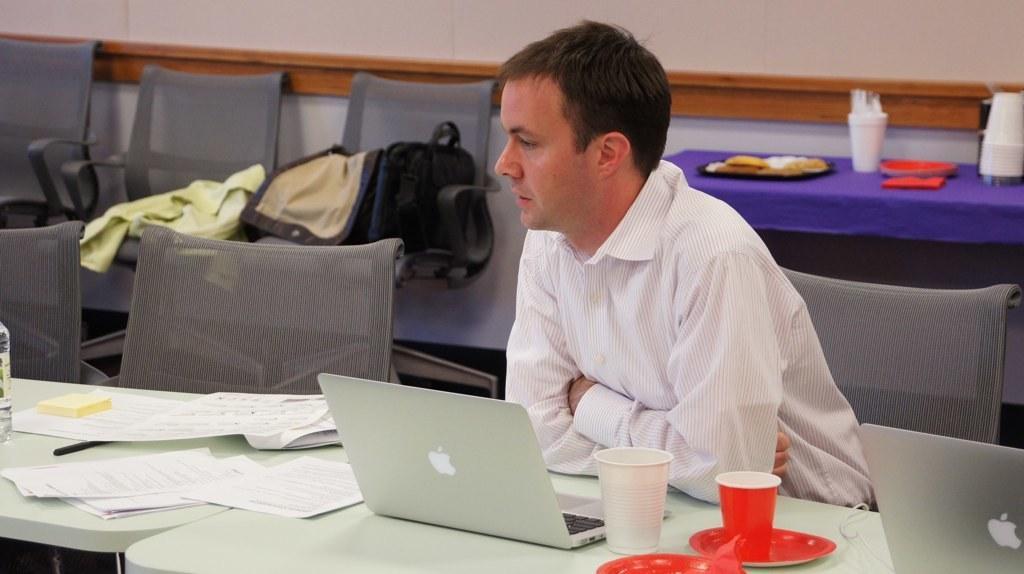Please provide a concise description of this image. In this image there is a man sitting on the chair. In front of him there is a table. On the table there are papers, laptops, plates, glasses and a bottle. To the left there are chairs. There are clothes and a luggage bag on a chair. Behind him there is another table. On that table there are plates and glasses. There is food on the plates. In the background there is the wall. 